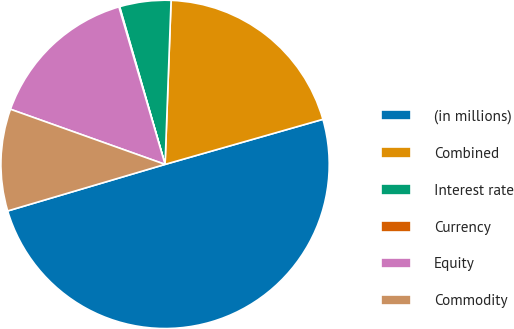<chart> <loc_0><loc_0><loc_500><loc_500><pie_chart><fcel>(in millions)<fcel>Combined<fcel>Interest rate<fcel>Currency<fcel>Equity<fcel>Commodity<nl><fcel>49.85%<fcel>19.99%<fcel>5.05%<fcel>0.07%<fcel>15.01%<fcel>10.03%<nl></chart> 